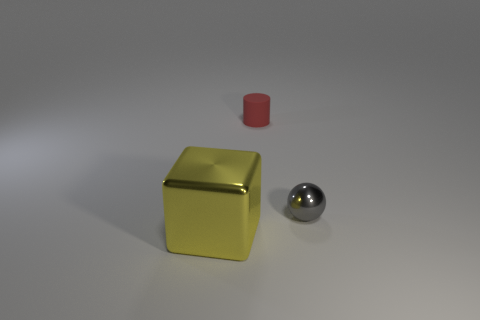There is a metallic object that is right of the red matte cylinder; is it the same color as the cylinder?
Ensure brevity in your answer.  No. What number of tiny things are either blocks or brown cylinders?
Your answer should be compact. 0. Does the metallic thing that is behind the block have the same size as the yellow shiny object?
Offer a terse response. No. What is the cylinder made of?
Give a very brief answer. Rubber. The object that is on the right side of the block and to the left of the gray metallic ball is made of what material?
Your response must be concise. Rubber. What number of objects are either shiny objects behind the yellow shiny block or rubber cylinders?
Your response must be concise. 2. Do the rubber cylinder and the tiny sphere have the same color?
Your answer should be compact. No. Are there any spheres of the same size as the yellow block?
Provide a short and direct response. No. How many things are on the left side of the gray ball and right of the large shiny thing?
Your answer should be very brief. 1. How many gray things are on the right side of the large yellow thing?
Offer a very short reply. 1. 